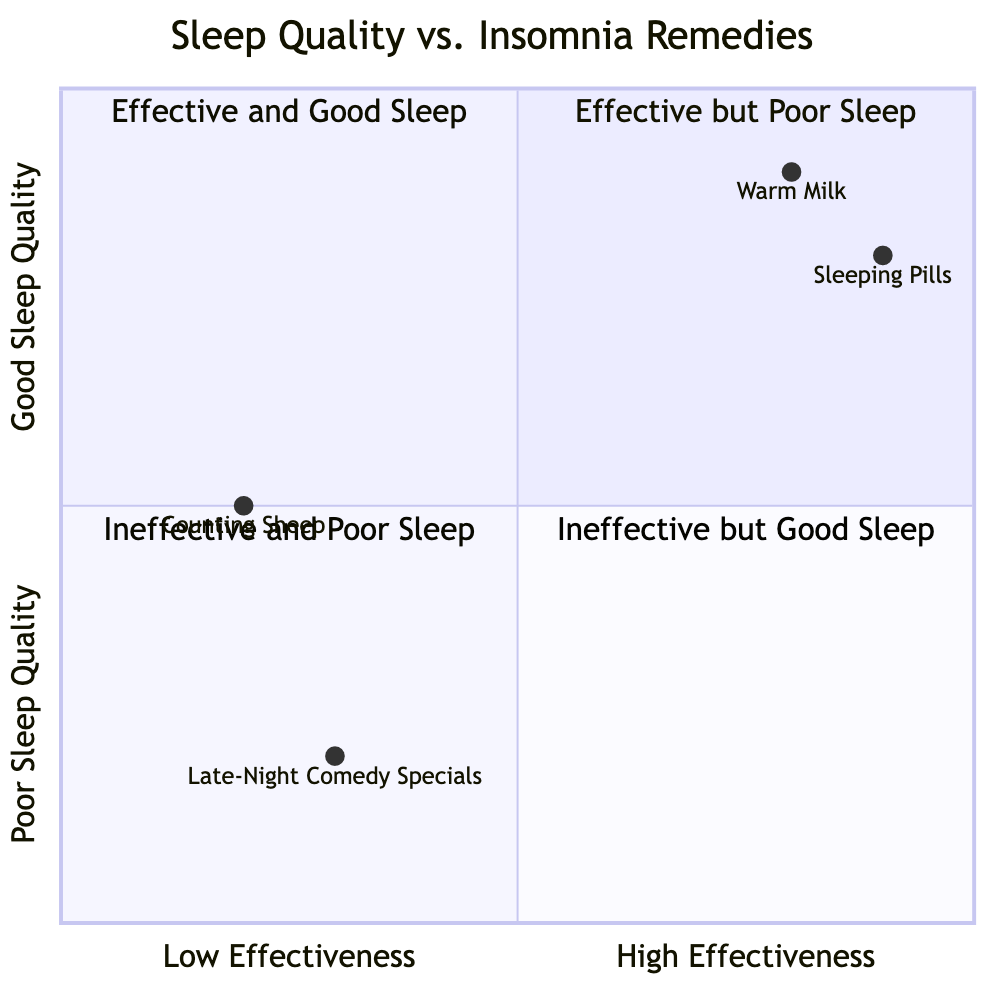What is the effectiveness of Warm Milk? Warm Milk is positioned high on the effectiveness axis, indicating it has a high effectiveness rating of 0.8, suggesting it is quite effective for improving sleep quality.
Answer: 0.8 Which insomnia remedy is classified as ineffective but leads to good sleep quality? Looking at the quadrant chart, Counting Sheep is positioned in the "Ineffective and Poor Sleep" section, while no remedies fall into the "Ineffective but Good Sleep" section, indicating none are classified that way.
Answer: None How does the effect of Sleeping Pills compare to Counting Sheep? Sleeping Pills are classified as effective with a score of 0.9, resulting in restful sleep, whereas Counting Sheep is rated low at 0.2, resulting in no effect on sleep quality. This shows Sleeping Pills are significantly more effective than Counting Sheep.
Answer: More effective What is the overall sleep quality effect of Late-Night Comedy Specials? Late-Night Comedy Specials are found at the lower end of the effectiveness axis (0.3) and in the restless sleep quality section, indicating they do not effectively improve sleep quality and lead to restlessness.
Answer: Restless Which insomnia remedy has the highest rating for sleep quality? Among all remedies, Sleeping Pills offer the highest sleep quality effect classified as restful with a score of 0.8.
Answer: Sleeping Pills How many remedies are categorized as having a restful effect on sleep quality? Analyzing the remedies, both Warm Milk and Sleeping Pills are reported to have a restful effect on sleep quality. Therefore, there are two remedies categorized as such.
Answer: 2 What is the average effectiveness of the remedies presented? To find the average effectiveness, we calculate (0.8 + 0.2 + 0.9 + 0.3) / 4 = 0.575. This number reflects the overall effectiveness across all insomnia remedies shown.
Answer: 0.575 What quadrant contains remedies that are ineffective and lead to poor sleep? Counting Sheep and Late-Night Comedy Specials fit into the "Ineffective and Poor Sleep" quadrant, indicating that both do not improve sleep quality and are not effective.
Answer: Ineffective and Poor Sleep How many remedies show a restful sleep quality effect? When examining the remedies, both Warm Milk and Sleeping Pills indicate a restful sleep quality effect, totaling two remedies.
Answer: 2 